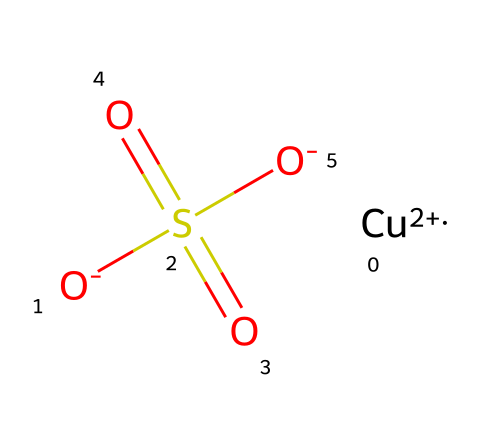How many sulfur atoms are in this molecule? The SMILES representation indicates the presence of one 'S' character, which corresponds to a single sulfur atom in the molecule.
Answer: one What is the oxidation state of copper in this compound? In the SMILES notation, the copper is represented as [Cu+2], indicating that it has an oxidation state of +2.
Answer: +2 How many oxygen atoms are present in copper sulfate? The SMILES contains four oxygen atoms marked with 'O' and the double-bonded oxygen in the sulfate, totaling four.
Answer: four What type of chemical bond connects the sulfur and oxygen in this compound? The bonds between sulfur and oxygen are typically covalent, as they share electrons to form stable molecules, influenced by the structure of the sulfate group.
Answer: covalent What role does copper sulfate play in agriculture? Copper sulfate is primarily used as a fungicide to control fungal diseases in plants, protecting crops against harmful pathogens.
Answer: fungicide Which part of this chemical structure contributes to its fungicidal properties? The copper ion ([Cu+2]) is responsible for the antifungal activity, as it can disrupt cellular processes in fungi.
Answer: copper ion 